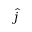Convert formula to latex. <formula><loc_0><loc_0><loc_500><loc_500>\hat { j }</formula> 